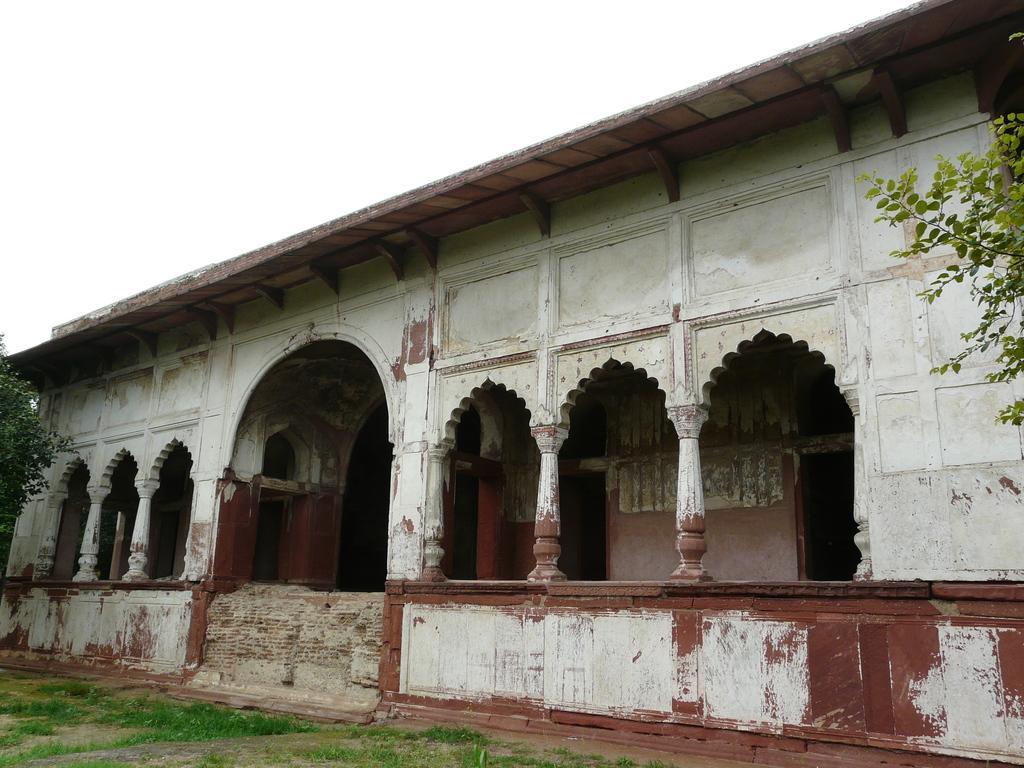Please provide a concise description of this image. Here I can see a building. On the right and left sides of the image I can see the trees. At the bottom of the image I can see the grass and at the top I can see the sky. 